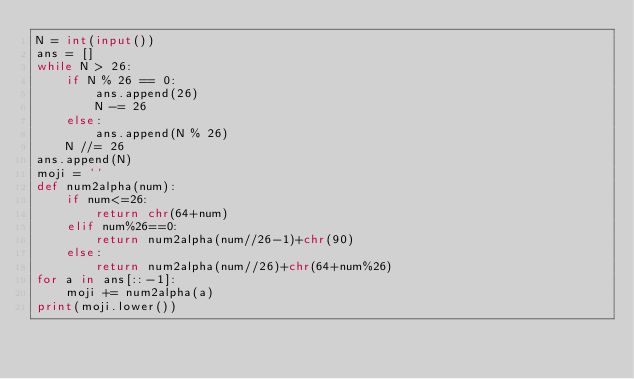<code> <loc_0><loc_0><loc_500><loc_500><_Python_>N = int(input())
ans = []
while N > 26:
    if N % 26 == 0:
        ans.append(26)
        N -= 26
    else:
        ans.append(N % 26)
    N //= 26
ans.append(N)
moji = ''
def num2alpha(num):
    if num<=26:
        return chr(64+num)
    elif num%26==0:
        return num2alpha(num//26-1)+chr(90)
    else:
        return num2alpha(num//26)+chr(64+num%26)
for a in ans[::-1]:
    moji += num2alpha(a)
print(moji.lower())</code> 